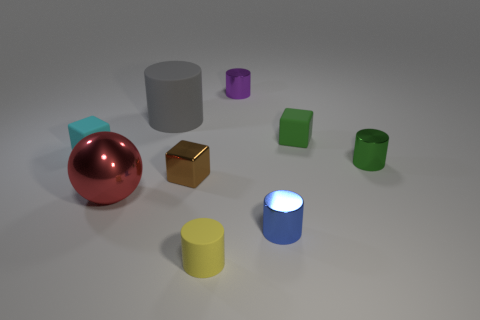Subtract all large cylinders. How many cylinders are left? 4 Subtract 1 cylinders. How many cylinders are left? 4 Add 1 big purple rubber balls. How many objects exist? 10 Subtract all cyan blocks. How many blocks are left? 2 Subtract 0 red cylinders. How many objects are left? 9 Subtract all cylinders. How many objects are left? 4 Subtract all green cylinders. Subtract all purple spheres. How many cylinders are left? 4 Subtract all large yellow rubber things. Subtract all big gray cylinders. How many objects are left? 8 Add 4 metal cylinders. How many metal cylinders are left? 7 Add 7 small brown cubes. How many small brown cubes exist? 8 